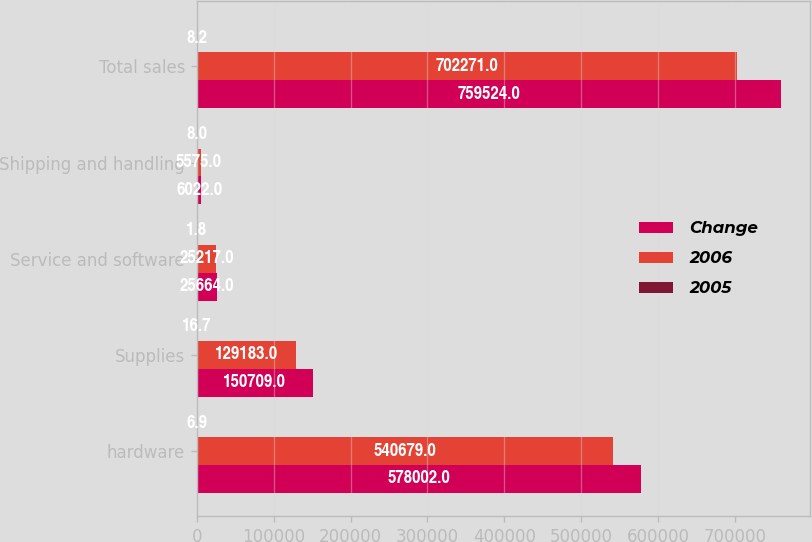<chart> <loc_0><loc_0><loc_500><loc_500><stacked_bar_chart><ecel><fcel>hardware<fcel>Supplies<fcel>Service and software<fcel>Shipping and handling<fcel>Total sales<nl><fcel>Change<fcel>578002<fcel>150709<fcel>25664<fcel>6022<fcel>759524<nl><fcel>2006<fcel>540679<fcel>129183<fcel>25217<fcel>5575<fcel>702271<nl><fcel>2005<fcel>6.9<fcel>16.7<fcel>1.8<fcel>8<fcel>8.2<nl></chart> 